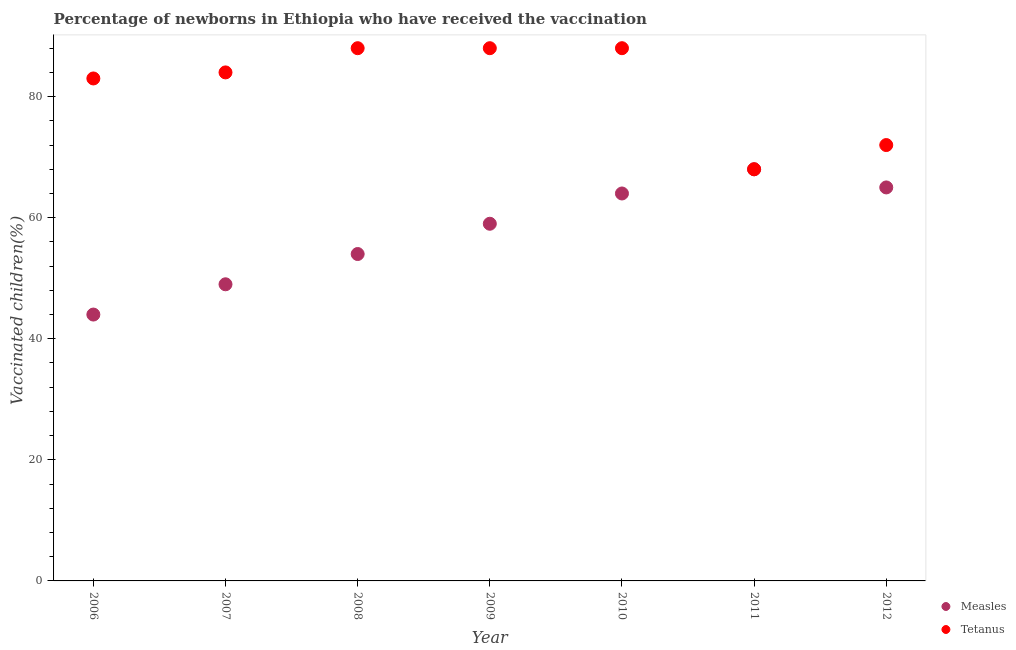How many different coloured dotlines are there?
Your answer should be compact. 2. What is the percentage of newborns who received vaccination for tetanus in 2006?
Offer a terse response. 83. Across all years, what is the maximum percentage of newborns who received vaccination for measles?
Offer a very short reply. 68. Across all years, what is the minimum percentage of newborns who received vaccination for tetanus?
Provide a short and direct response. 68. In which year was the percentage of newborns who received vaccination for measles maximum?
Your answer should be very brief. 2011. What is the total percentage of newborns who received vaccination for tetanus in the graph?
Provide a succinct answer. 571. What is the difference between the percentage of newborns who received vaccination for tetanus in 2009 and that in 2011?
Your response must be concise. 20. What is the difference between the percentage of newborns who received vaccination for measles in 2010 and the percentage of newborns who received vaccination for tetanus in 2008?
Keep it short and to the point. -24. What is the average percentage of newborns who received vaccination for tetanus per year?
Give a very brief answer. 81.57. In the year 2012, what is the difference between the percentage of newborns who received vaccination for tetanus and percentage of newborns who received vaccination for measles?
Your answer should be very brief. 7. In how many years, is the percentage of newborns who received vaccination for measles greater than 72 %?
Your answer should be compact. 0. What is the ratio of the percentage of newborns who received vaccination for measles in 2009 to that in 2011?
Your answer should be compact. 0.87. What is the difference between the highest and the second highest percentage of newborns who received vaccination for tetanus?
Offer a terse response. 0. What is the difference between the highest and the lowest percentage of newborns who received vaccination for measles?
Provide a succinct answer. 24. In how many years, is the percentage of newborns who received vaccination for measles greater than the average percentage of newborns who received vaccination for measles taken over all years?
Your answer should be very brief. 4. Is the percentage of newborns who received vaccination for measles strictly less than the percentage of newborns who received vaccination for tetanus over the years?
Offer a very short reply. No. How many dotlines are there?
Offer a very short reply. 2. Does the graph contain grids?
Give a very brief answer. No. What is the title of the graph?
Offer a very short reply. Percentage of newborns in Ethiopia who have received the vaccination. What is the label or title of the X-axis?
Your answer should be compact. Year. What is the label or title of the Y-axis?
Keep it short and to the point. Vaccinated children(%)
. What is the Vaccinated children(%)
 of Measles in 2006?
Offer a very short reply. 44. What is the Vaccinated children(%)
 of Measles in 2010?
Offer a very short reply. 64. What is the Vaccinated children(%)
 in Tetanus in 2010?
Provide a succinct answer. 88. Across all years, what is the maximum Vaccinated children(%)
 of Tetanus?
Provide a short and direct response. 88. Across all years, what is the minimum Vaccinated children(%)
 in Tetanus?
Keep it short and to the point. 68. What is the total Vaccinated children(%)
 in Measles in the graph?
Provide a succinct answer. 403. What is the total Vaccinated children(%)
 of Tetanus in the graph?
Your answer should be compact. 571. What is the difference between the Vaccinated children(%)
 of Measles in 2006 and that in 2007?
Offer a terse response. -5. What is the difference between the Vaccinated children(%)
 in Tetanus in 2006 and that in 2007?
Offer a terse response. -1. What is the difference between the Vaccinated children(%)
 of Tetanus in 2006 and that in 2008?
Give a very brief answer. -5. What is the difference between the Vaccinated children(%)
 in Measles in 2006 and that in 2010?
Provide a short and direct response. -20. What is the difference between the Vaccinated children(%)
 of Tetanus in 2006 and that in 2010?
Your response must be concise. -5. What is the difference between the Vaccinated children(%)
 of Tetanus in 2006 and that in 2012?
Your response must be concise. 11. What is the difference between the Vaccinated children(%)
 of Measles in 2007 and that in 2009?
Your response must be concise. -10. What is the difference between the Vaccinated children(%)
 of Measles in 2007 and that in 2012?
Give a very brief answer. -16. What is the difference between the Vaccinated children(%)
 in Tetanus in 2007 and that in 2012?
Offer a very short reply. 12. What is the difference between the Vaccinated children(%)
 of Measles in 2008 and that in 2009?
Offer a terse response. -5. What is the difference between the Vaccinated children(%)
 of Tetanus in 2008 and that in 2009?
Keep it short and to the point. 0. What is the difference between the Vaccinated children(%)
 of Measles in 2008 and that in 2010?
Your answer should be very brief. -10. What is the difference between the Vaccinated children(%)
 in Tetanus in 2008 and that in 2010?
Your answer should be compact. 0. What is the difference between the Vaccinated children(%)
 in Measles in 2008 and that in 2011?
Keep it short and to the point. -14. What is the difference between the Vaccinated children(%)
 of Tetanus in 2008 and that in 2011?
Make the answer very short. 20. What is the difference between the Vaccinated children(%)
 of Measles in 2009 and that in 2010?
Ensure brevity in your answer.  -5. What is the difference between the Vaccinated children(%)
 of Tetanus in 2009 and that in 2012?
Your answer should be compact. 16. What is the difference between the Vaccinated children(%)
 of Tetanus in 2011 and that in 2012?
Keep it short and to the point. -4. What is the difference between the Vaccinated children(%)
 of Measles in 2006 and the Vaccinated children(%)
 of Tetanus in 2007?
Provide a short and direct response. -40. What is the difference between the Vaccinated children(%)
 of Measles in 2006 and the Vaccinated children(%)
 of Tetanus in 2008?
Give a very brief answer. -44. What is the difference between the Vaccinated children(%)
 of Measles in 2006 and the Vaccinated children(%)
 of Tetanus in 2009?
Offer a very short reply. -44. What is the difference between the Vaccinated children(%)
 of Measles in 2006 and the Vaccinated children(%)
 of Tetanus in 2010?
Ensure brevity in your answer.  -44. What is the difference between the Vaccinated children(%)
 of Measles in 2006 and the Vaccinated children(%)
 of Tetanus in 2011?
Your answer should be compact. -24. What is the difference between the Vaccinated children(%)
 of Measles in 2006 and the Vaccinated children(%)
 of Tetanus in 2012?
Provide a short and direct response. -28. What is the difference between the Vaccinated children(%)
 in Measles in 2007 and the Vaccinated children(%)
 in Tetanus in 2008?
Your answer should be very brief. -39. What is the difference between the Vaccinated children(%)
 of Measles in 2007 and the Vaccinated children(%)
 of Tetanus in 2009?
Offer a very short reply. -39. What is the difference between the Vaccinated children(%)
 in Measles in 2007 and the Vaccinated children(%)
 in Tetanus in 2010?
Your answer should be compact. -39. What is the difference between the Vaccinated children(%)
 of Measles in 2008 and the Vaccinated children(%)
 of Tetanus in 2009?
Ensure brevity in your answer.  -34. What is the difference between the Vaccinated children(%)
 in Measles in 2008 and the Vaccinated children(%)
 in Tetanus in 2010?
Offer a very short reply. -34. What is the difference between the Vaccinated children(%)
 of Measles in 2008 and the Vaccinated children(%)
 of Tetanus in 2011?
Keep it short and to the point. -14. What is the difference between the Vaccinated children(%)
 of Measles in 2008 and the Vaccinated children(%)
 of Tetanus in 2012?
Ensure brevity in your answer.  -18. What is the difference between the Vaccinated children(%)
 of Measles in 2009 and the Vaccinated children(%)
 of Tetanus in 2011?
Offer a terse response. -9. What is the difference between the Vaccinated children(%)
 of Measles in 2010 and the Vaccinated children(%)
 of Tetanus in 2011?
Keep it short and to the point. -4. What is the difference between the Vaccinated children(%)
 of Measles in 2011 and the Vaccinated children(%)
 of Tetanus in 2012?
Keep it short and to the point. -4. What is the average Vaccinated children(%)
 in Measles per year?
Provide a short and direct response. 57.57. What is the average Vaccinated children(%)
 in Tetanus per year?
Offer a terse response. 81.57. In the year 2006, what is the difference between the Vaccinated children(%)
 in Measles and Vaccinated children(%)
 in Tetanus?
Offer a very short reply. -39. In the year 2007, what is the difference between the Vaccinated children(%)
 of Measles and Vaccinated children(%)
 of Tetanus?
Ensure brevity in your answer.  -35. In the year 2008, what is the difference between the Vaccinated children(%)
 in Measles and Vaccinated children(%)
 in Tetanus?
Offer a very short reply. -34. In the year 2009, what is the difference between the Vaccinated children(%)
 of Measles and Vaccinated children(%)
 of Tetanus?
Provide a succinct answer. -29. In the year 2011, what is the difference between the Vaccinated children(%)
 in Measles and Vaccinated children(%)
 in Tetanus?
Offer a terse response. 0. In the year 2012, what is the difference between the Vaccinated children(%)
 of Measles and Vaccinated children(%)
 of Tetanus?
Ensure brevity in your answer.  -7. What is the ratio of the Vaccinated children(%)
 of Measles in 2006 to that in 2007?
Offer a very short reply. 0.9. What is the ratio of the Vaccinated children(%)
 in Measles in 2006 to that in 2008?
Your answer should be very brief. 0.81. What is the ratio of the Vaccinated children(%)
 of Tetanus in 2006 to that in 2008?
Your response must be concise. 0.94. What is the ratio of the Vaccinated children(%)
 of Measles in 2006 to that in 2009?
Ensure brevity in your answer.  0.75. What is the ratio of the Vaccinated children(%)
 in Tetanus in 2006 to that in 2009?
Offer a terse response. 0.94. What is the ratio of the Vaccinated children(%)
 in Measles in 2006 to that in 2010?
Your answer should be compact. 0.69. What is the ratio of the Vaccinated children(%)
 of Tetanus in 2006 to that in 2010?
Your answer should be compact. 0.94. What is the ratio of the Vaccinated children(%)
 in Measles in 2006 to that in 2011?
Your response must be concise. 0.65. What is the ratio of the Vaccinated children(%)
 of Tetanus in 2006 to that in 2011?
Give a very brief answer. 1.22. What is the ratio of the Vaccinated children(%)
 in Measles in 2006 to that in 2012?
Your response must be concise. 0.68. What is the ratio of the Vaccinated children(%)
 in Tetanus in 2006 to that in 2012?
Make the answer very short. 1.15. What is the ratio of the Vaccinated children(%)
 of Measles in 2007 to that in 2008?
Make the answer very short. 0.91. What is the ratio of the Vaccinated children(%)
 of Tetanus in 2007 to that in 2008?
Ensure brevity in your answer.  0.95. What is the ratio of the Vaccinated children(%)
 of Measles in 2007 to that in 2009?
Offer a very short reply. 0.83. What is the ratio of the Vaccinated children(%)
 of Tetanus in 2007 to that in 2009?
Your answer should be very brief. 0.95. What is the ratio of the Vaccinated children(%)
 of Measles in 2007 to that in 2010?
Your response must be concise. 0.77. What is the ratio of the Vaccinated children(%)
 of Tetanus in 2007 to that in 2010?
Make the answer very short. 0.95. What is the ratio of the Vaccinated children(%)
 in Measles in 2007 to that in 2011?
Give a very brief answer. 0.72. What is the ratio of the Vaccinated children(%)
 of Tetanus in 2007 to that in 2011?
Offer a very short reply. 1.24. What is the ratio of the Vaccinated children(%)
 of Measles in 2007 to that in 2012?
Keep it short and to the point. 0.75. What is the ratio of the Vaccinated children(%)
 in Measles in 2008 to that in 2009?
Your answer should be very brief. 0.92. What is the ratio of the Vaccinated children(%)
 in Tetanus in 2008 to that in 2009?
Make the answer very short. 1. What is the ratio of the Vaccinated children(%)
 in Measles in 2008 to that in 2010?
Offer a terse response. 0.84. What is the ratio of the Vaccinated children(%)
 of Measles in 2008 to that in 2011?
Make the answer very short. 0.79. What is the ratio of the Vaccinated children(%)
 in Tetanus in 2008 to that in 2011?
Your response must be concise. 1.29. What is the ratio of the Vaccinated children(%)
 in Measles in 2008 to that in 2012?
Your response must be concise. 0.83. What is the ratio of the Vaccinated children(%)
 of Tetanus in 2008 to that in 2012?
Make the answer very short. 1.22. What is the ratio of the Vaccinated children(%)
 in Measles in 2009 to that in 2010?
Make the answer very short. 0.92. What is the ratio of the Vaccinated children(%)
 of Tetanus in 2009 to that in 2010?
Make the answer very short. 1. What is the ratio of the Vaccinated children(%)
 in Measles in 2009 to that in 2011?
Provide a short and direct response. 0.87. What is the ratio of the Vaccinated children(%)
 in Tetanus in 2009 to that in 2011?
Your answer should be compact. 1.29. What is the ratio of the Vaccinated children(%)
 in Measles in 2009 to that in 2012?
Your answer should be compact. 0.91. What is the ratio of the Vaccinated children(%)
 of Tetanus in 2009 to that in 2012?
Give a very brief answer. 1.22. What is the ratio of the Vaccinated children(%)
 in Measles in 2010 to that in 2011?
Give a very brief answer. 0.94. What is the ratio of the Vaccinated children(%)
 in Tetanus in 2010 to that in 2011?
Provide a short and direct response. 1.29. What is the ratio of the Vaccinated children(%)
 in Measles in 2010 to that in 2012?
Keep it short and to the point. 0.98. What is the ratio of the Vaccinated children(%)
 in Tetanus in 2010 to that in 2012?
Your response must be concise. 1.22. What is the ratio of the Vaccinated children(%)
 in Measles in 2011 to that in 2012?
Give a very brief answer. 1.05. What is the difference between the highest and the second highest Vaccinated children(%)
 of Tetanus?
Provide a succinct answer. 0. What is the difference between the highest and the lowest Vaccinated children(%)
 in Tetanus?
Provide a succinct answer. 20. 